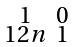<formula> <loc_0><loc_0><loc_500><loc_500>\begin{smallmatrix} 1 & 0 \\ 1 2 n & 1 \end{smallmatrix}</formula> 